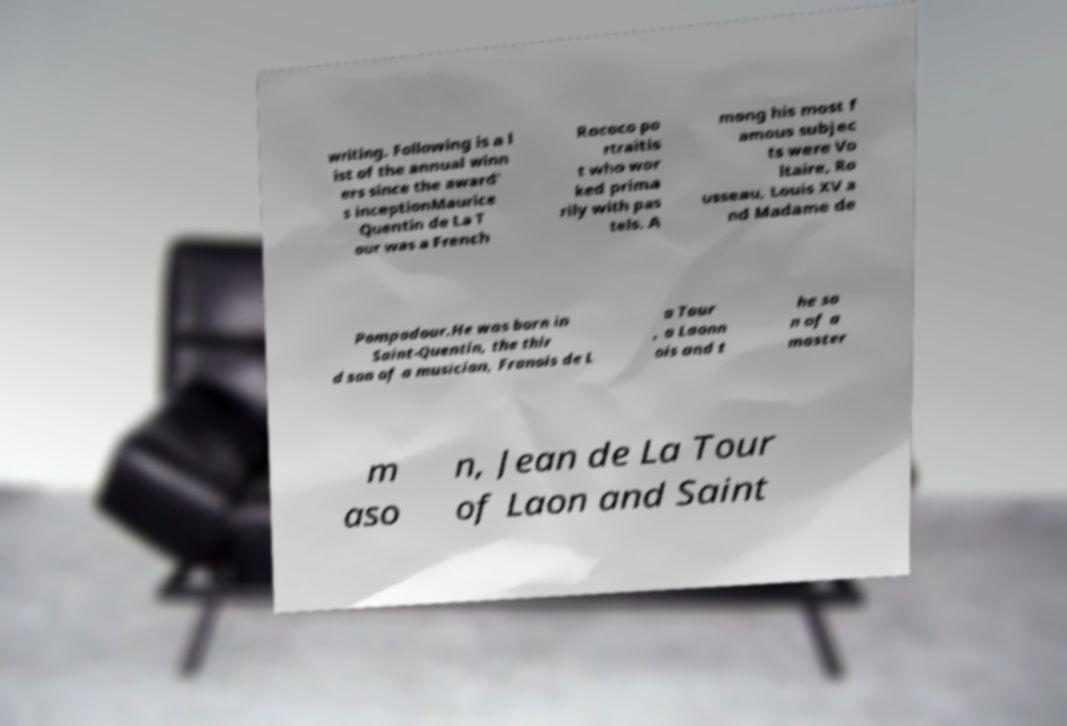Could you assist in decoding the text presented in this image and type it out clearly? writing. Following is a l ist of the annual winn ers since the award' s inceptionMaurice Quentin de La T our was a French Rococo po rtraitis t who wor ked prima rily with pas tels. A mong his most f amous subjec ts were Vo ltaire, Ro usseau, Louis XV a nd Madame de Pompadour.He was born in Saint-Quentin, the thir d son of a musician, Franois de L a Tour , a Laonn ois and t he so n of a master m aso n, Jean de La Tour of Laon and Saint 